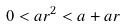<formula> <loc_0><loc_0><loc_500><loc_500>0 < a r ^ { 2 } < a + a r</formula> 